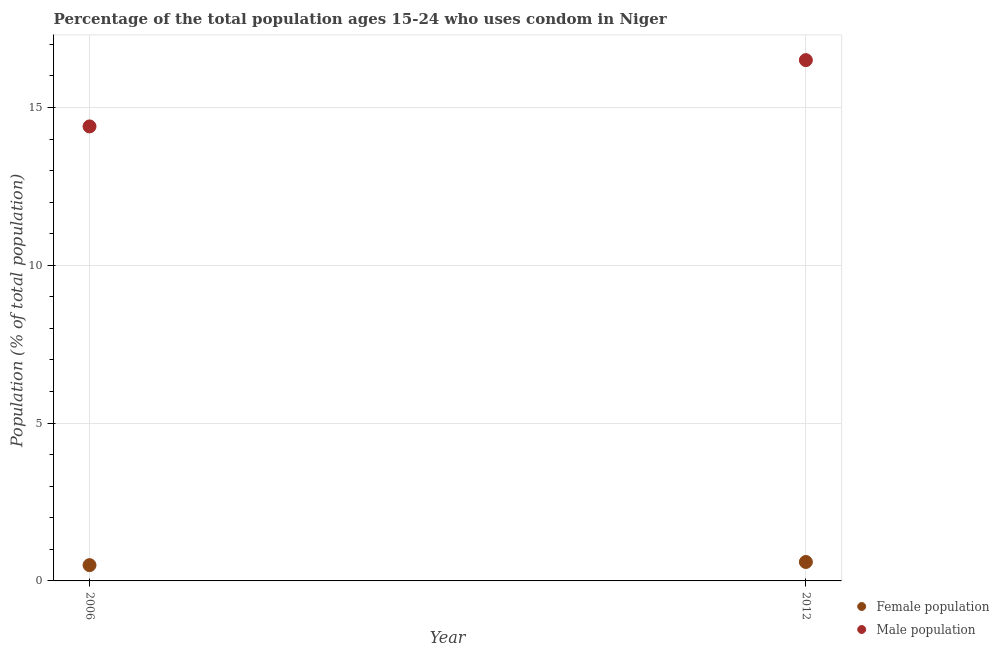How many different coloured dotlines are there?
Offer a very short reply. 2. Is the number of dotlines equal to the number of legend labels?
Provide a succinct answer. Yes. Across all years, what is the minimum female population?
Ensure brevity in your answer.  0.5. In which year was the female population maximum?
Keep it short and to the point. 2012. What is the difference between the female population in 2006 and that in 2012?
Make the answer very short. -0.1. What is the difference between the female population in 2006 and the male population in 2012?
Your answer should be very brief. -16. What is the average female population per year?
Ensure brevity in your answer.  0.55. In the year 2006, what is the difference between the male population and female population?
Give a very brief answer. 13.9. In how many years, is the male population greater than 13 %?
Provide a succinct answer. 2. What is the ratio of the male population in 2006 to that in 2012?
Offer a very short reply. 0.87. In how many years, is the female population greater than the average female population taken over all years?
Give a very brief answer. 1. Does the female population monotonically increase over the years?
Keep it short and to the point. Yes. Is the male population strictly greater than the female population over the years?
Offer a very short reply. Yes. Is the female population strictly less than the male population over the years?
Provide a short and direct response. Yes. How many dotlines are there?
Provide a short and direct response. 2. How many years are there in the graph?
Offer a very short reply. 2. What is the difference between two consecutive major ticks on the Y-axis?
Provide a succinct answer. 5. Are the values on the major ticks of Y-axis written in scientific E-notation?
Offer a terse response. No. Does the graph contain grids?
Keep it short and to the point. Yes. What is the title of the graph?
Your answer should be very brief. Percentage of the total population ages 15-24 who uses condom in Niger. Does "Forest land" appear as one of the legend labels in the graph?
Provide a short and direct response. No. What is the label or title of the Y-axis?
Give a very brief answer. Population (% of total population) . What is the Population (% of total population)  of Female population in 2006?
Ensure brevity in your answer.  0.5. What is the Population (% of total population)  of Female population in 2012?
Keep it short and to the point. 0.6. What is the Population (% of total population)  in Male population in 2012?
Offer a very short reply. 16.5. Across all years, what is the maximum Population (% of total population)  in Female population?
Make the answer very short. 0.6. Across all years, what is the minimum Population (% of total population)  in Male population?
Ensure brevity in your answer.  14.4. What is the total Population (% of total population)  in Male population in the graph?
Your answer should be compact. 30.9. What is the difference between the Population (% of total population)  in Female population in 2006 and that in 2012?
Your answer should be very brief. -0.1. What is the difference between the Population (% of total population)  of Male population in 2006 and that in 2012?
Your response must be concise. -2.1. What is the difference between the Population (% of total population)  of Female population in 2006 and the Population (% of total population)  of Male population in 2012?
Give a very brief answer. -16. What is the average Population (% of total population)  in Female population per year?
Your answer should be very brief. 0.55. What is the average Population (% of total population)  in Male population per year?
Keep it short and to the point. 15.45. In the year 2012, what is the difference between the Population (% of total population)  in Female population and Population (% of total population)  in Male population?
Your answer should be compact. -15.9. What is the ratio of the Population (% of total population)  of Female population in 2006 to that in 2012?
Ensure brevity in your answer.  0.83. What is the ratio of the Population (% of total population)  of Male population in 2006 to that in 2012?
Offer a very short reply. 0.87. What is the difference between the highest and the second highest Population (% of total population)  in Female population?
Ensure brevity in your answer.  0.1. What is the difference between the highest and the second highest Population (% of total population)  of Male population?
Keep it short and to the point. 2.1. What is the difference between the highest and the lowest Population (% of total population)  in Female population?
Provide a short and direct response. 0.1. What is the difference between the highest and the lowest Population (% of total population)  of Male population?
Make the answer very short. 2.1. 